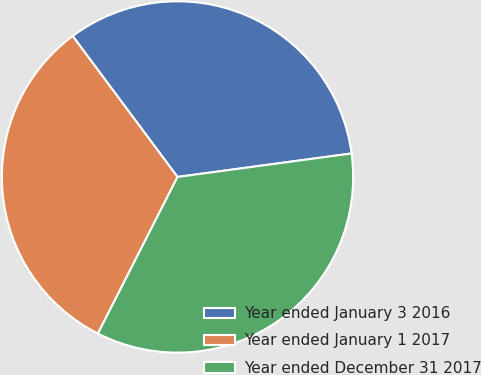<chart> <loc_0><loc_0><loc_500><loc_500><pie_chart><fcel>Year ended January 3 2016<fcel>Year ended January 1 2017<fcel>Year ended December 31 2017<nl><fcel>33.05%<fcel>32.33%<fcel>34.62%<nl></chart> 